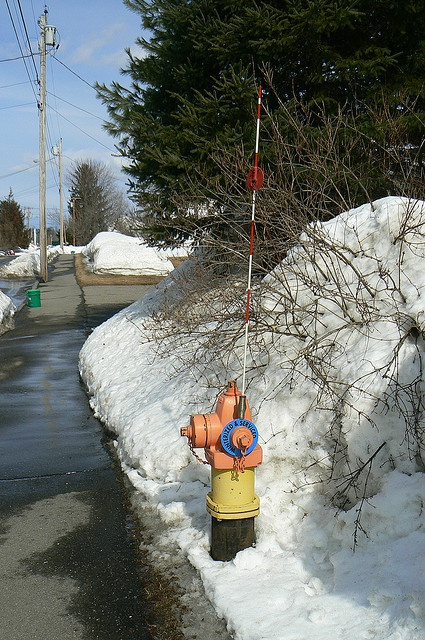Describe the objects in this image and their specific colors. I can see a fire hydrant in darkgray, tan, khaki, maroon, and olive tones in this image. 